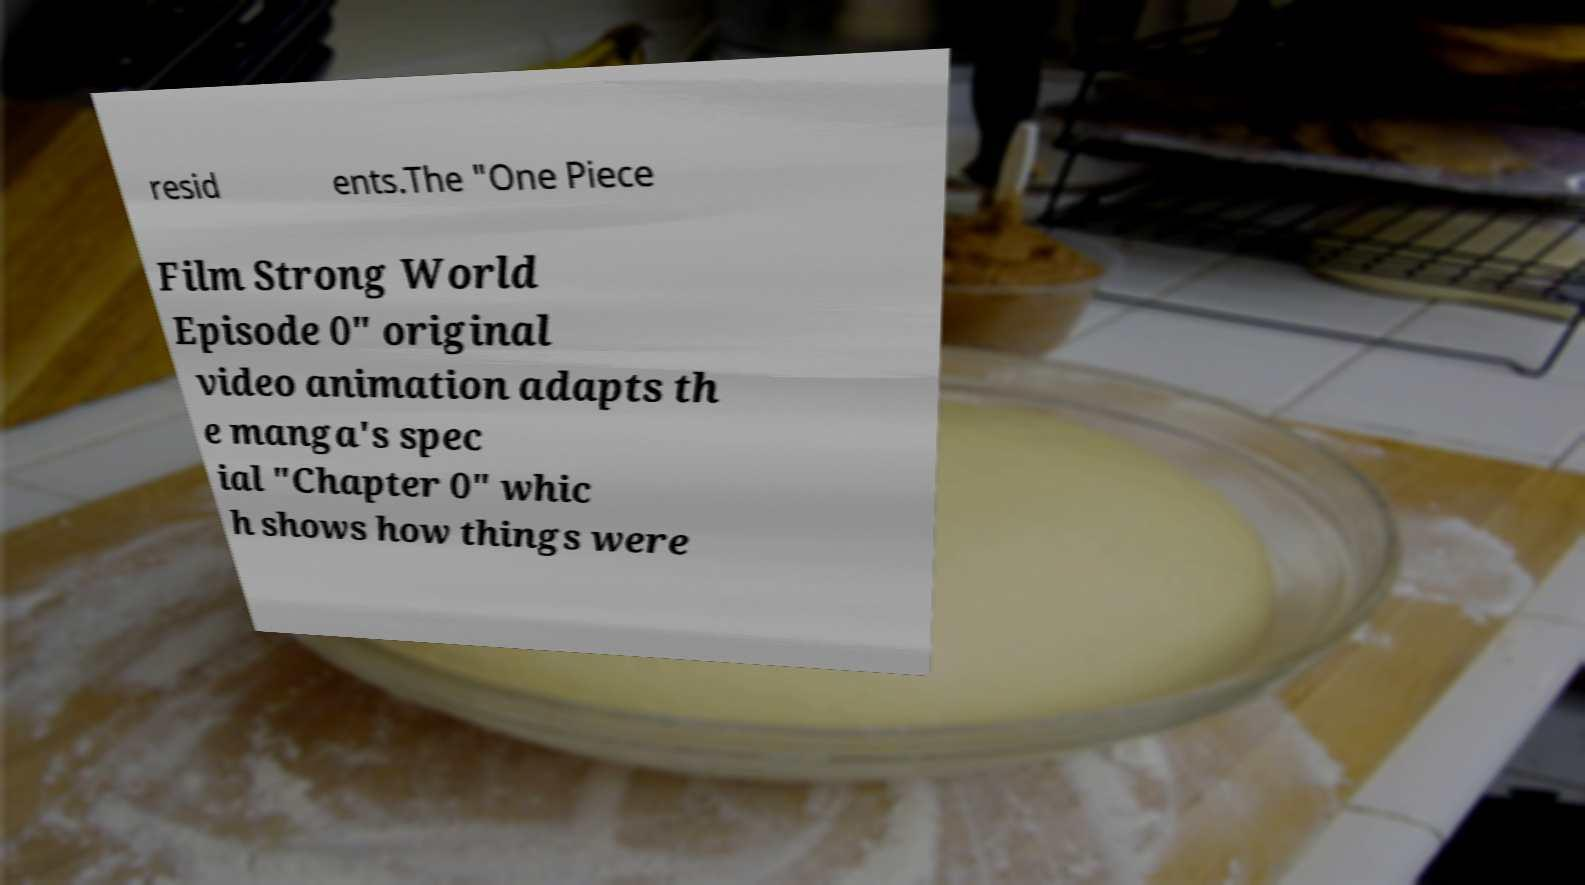Could you assist in decoding the text presented in this image and type it out clearly? resid ents.The "One Piece Film Strong World Episode 0" original video animation adapts th e manga's spec ial "Chapter 0" whic h shows how things were 